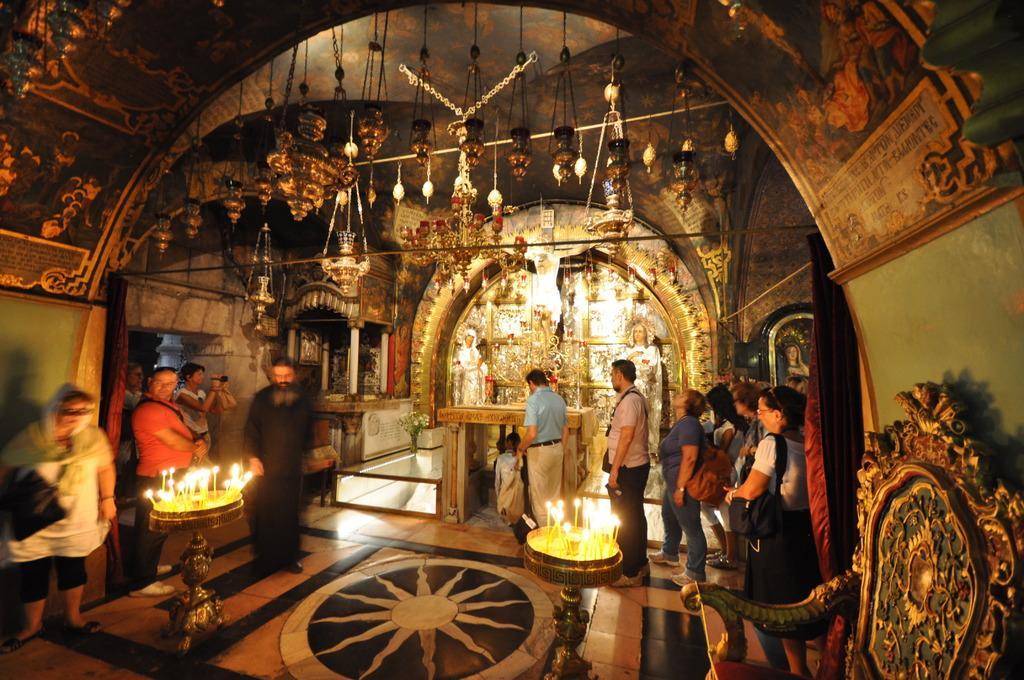Describe this image in one or two sentences. In this image there are a group of people standing in a hall, beside them there is a stand where so candles are blowing, and some objects hanging from the roof, also there are some antique things near the wall. 